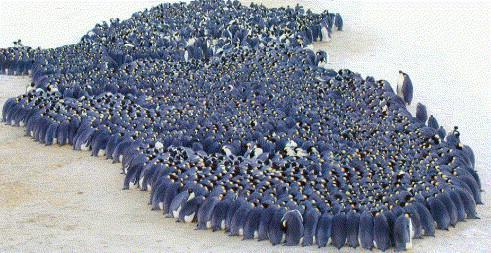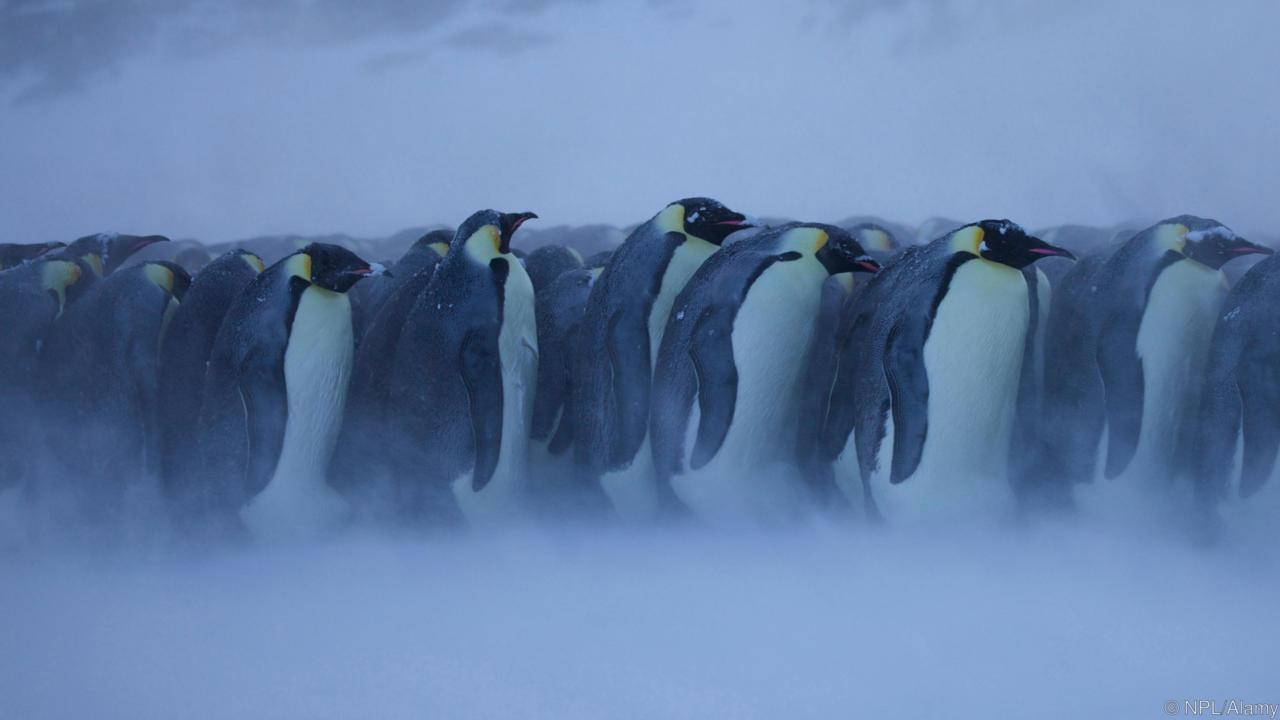The first image is the image on the left, the second image is the image on the right. Assess this claim about the two images: "There are penguins huddled in the center of the images.". Correct or not? Answer yes or no. Yes. 